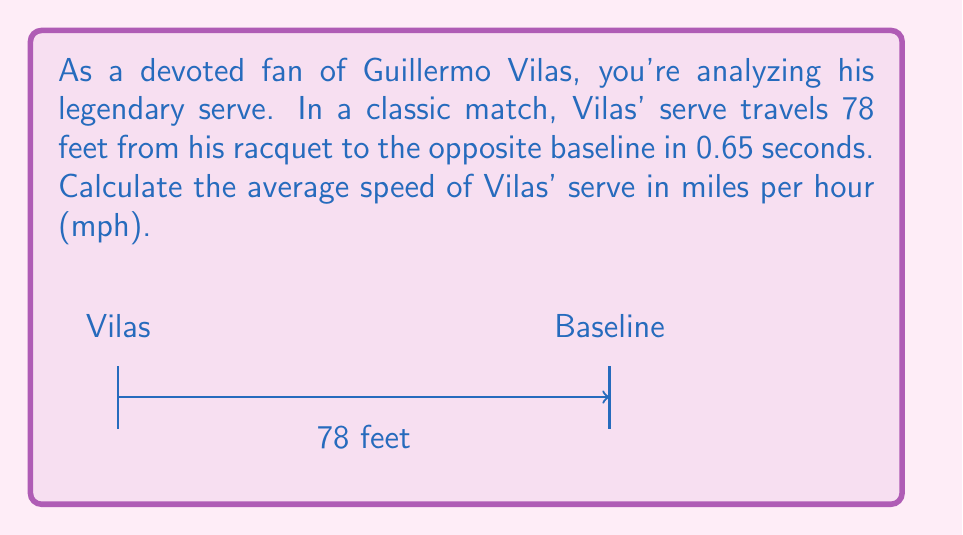Provide a solution to this math problem. To calculate the average speed of Guillermo Vilas' serve, we'll use the formula:

$$ \text{Average Speed} = \frac{\text{Distance}}{\text{Time}} $$

Given:
- Distance = 78 feet
- Time = 0.65 seconds

Step 1: Calculate the speed in feet per second (ft/s).
$$ \text{Speed} = \frac{78 \text{ ft}}{0.65 \text{ s}} = 120 \text{ ft/s} $$

Step 2: Convert feet per second to miles per hour.
There are 5280 feet in a mile and 3600 seconds in an hour.

$$ 120 \frac{\text{ft}}{\text{s}} \times \frac{3600 \text{ s}}{1 \text{ hour}} \times \frac{1 \text{ mile}}{5280 \text{ ft}} = 81.82 \text{ mph} $$

Step 3: Round to the nearest whole number.
$$ 81.82 \text{ mph} \approx 82 \text{ mph} $$

Therefore, the average speed of Guillermo Vilas' serve is approximately 82 mph.
Answer: 82 mph 